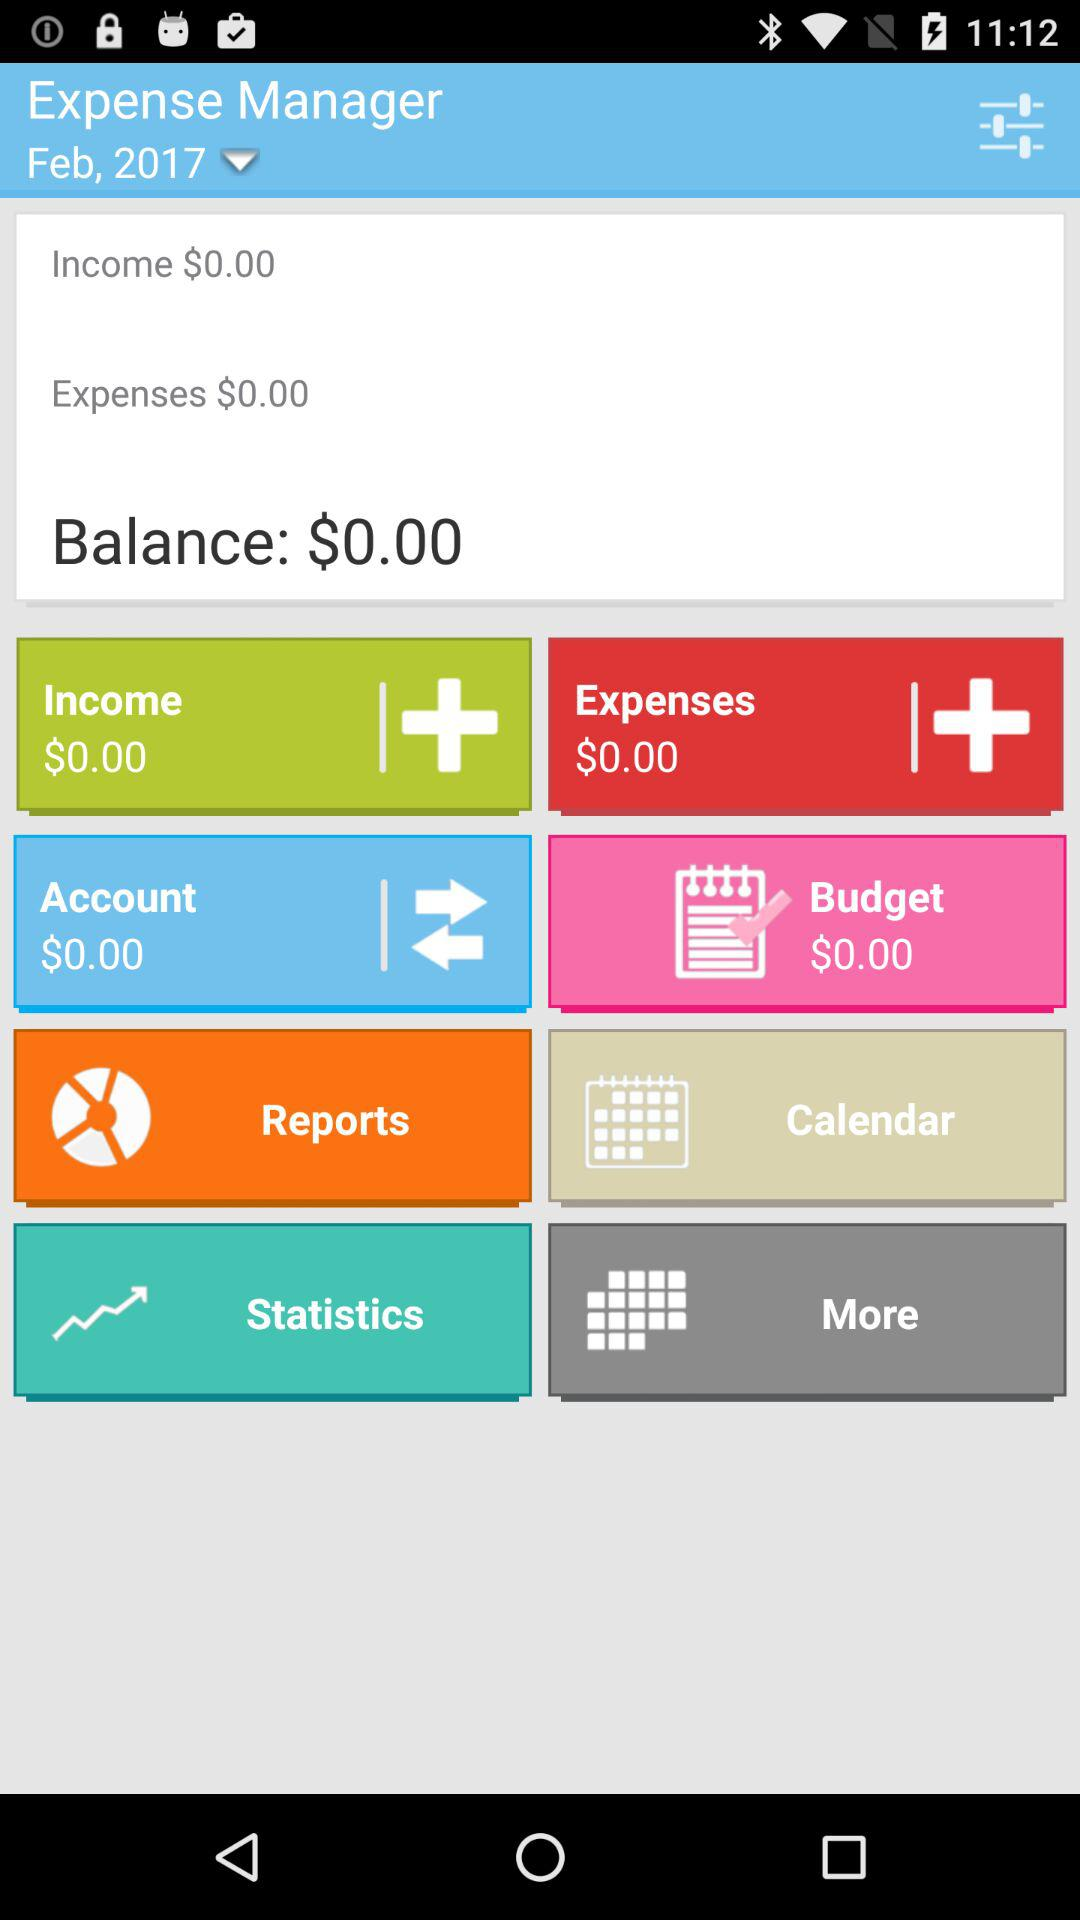What is the income shown on the screen? The income shown on the screen is $0.00. 